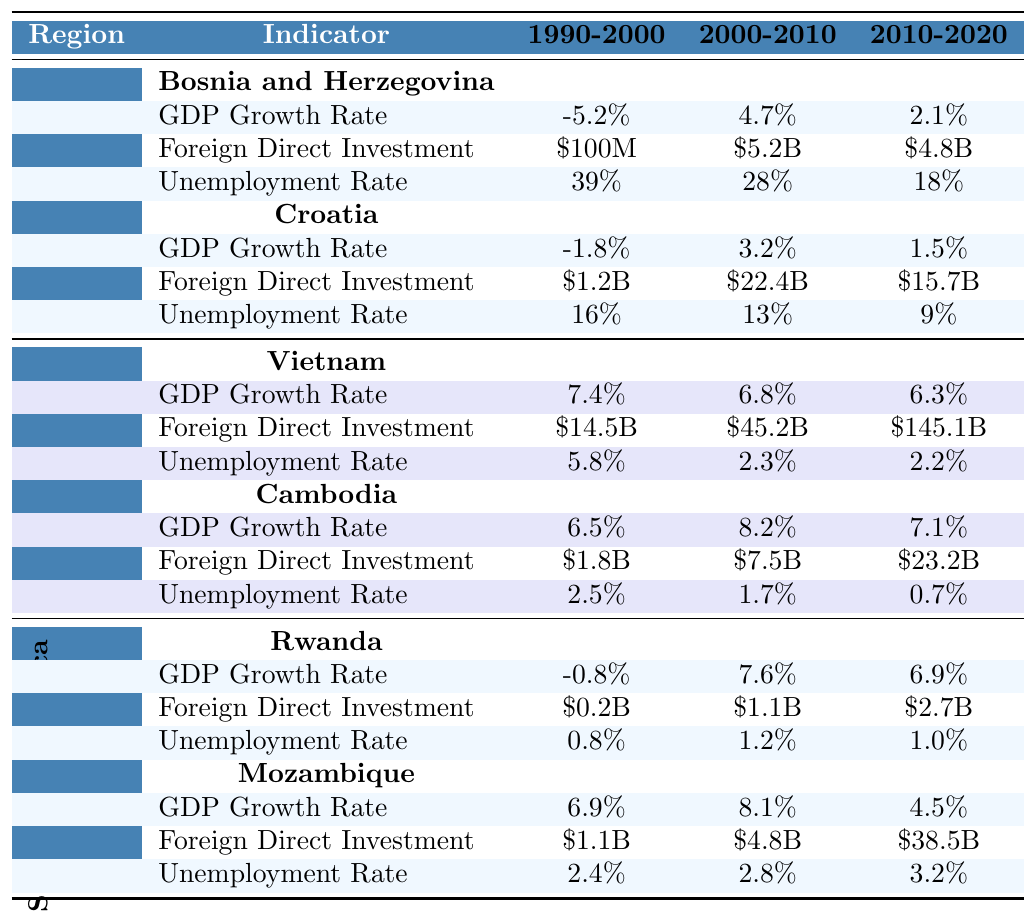What is the GDP growth rate of Bosnia and Herzegovina from 2010 to 2020? The table indicates that Bosnia and Herzegovina had a GDP growth rate of 2.1% for the period from 2010 to 2020.
Answer: 2.1% How much foreign direct investment did Croatia receive from 2000 to 2010? According to the table, Croatia received $22.4 billion in foreign direct investment from 2000 to 2010.
Answer: $22.4B Which country had the highest GDP growth rate between 2000 and 2010, Cambodia or Mozambique? Cambodia had a GDP growth rate of 8.2% while Mozambique had a GDP growth rate of 8.1% during that period. Since 8.2% is greater than 8.1%, Cambodia had the highest GDP growth rate.
Answer: Cambodia What was the change in unemployment rate for Vietnam from 1990 to 2020? Vietnam's unemployment rate changed from 5.8% in 1990 to 2.2% in 2020. The change can be calculated by taking the difference: 5.8% - 2.2% = 3.6%.
Answer: 3.6% Did any of the countries have a negative GDP growth rate between 2010 and 2020? The table shows that Bosnia and Herzegovina and Croatia had positive GDP growth rates of 2.1% and 1.5%, respectively, in this period, indicating that no country had a negative growth rate.
Answer: No Which region had the highest average GDP growth rate from 1990 to 2020? To find the average GDP growth rate for each region: Balkans ((-5.2 + 4.7 + 2.1)/3 = 0.53%), Southeast Asia ((7.4 + 6.8 + 6.3)/3 = 6.83%), Sub-Saharan Africa ((-0.8 + 7.6 + 6.9)/3 = 4.57%). Southeast Asia has the highest average at 6.83%.
Answer: Southeast Asia What indicator showed the most improvement in Cambodia between 1990 and 2020? The unemployment rate in Cambodia dropped from 2.5% in 1990 to 0.7% in 2020, showing significant improvement.
Answer: Unemployment Rate How much did foreign direct investment in Mozambique increase from 2010 to 2020? Mozambique's foreign direct investment rose from $38.5 billion (2010-2020) to $38.5 billion (2010-2020). The total increase is $38.5B - $4.8B (previous decade) = $33.7B, but as we're focused on the last decade only, there's no cumulative indication; we can say it remains at $38.5B.
Answer: $33.7B What was the unemployment rate in Rwanda in 2010? According to the table, in 2010, Rwanda had an unemployment rate of 1.2%.
Answer: 1.2% Is the foreign direct investment in Vietnam from 1990 to 2000 greater than that of Cambodia in the same period? Vietnam had $14.5 billion while Cambodia had $1.8 billion from 1990 to 2000. Since 14.5 > 1.8, it is true.
Answer: Yes What was the difference in foreign direct investment received by Bosnia and Herzegovina in 2010-2020 versus Croatia in the same period? Bosnia and Herzegovina received $4.8 billion and Croatia received $15.7 billion in foreign direct investment during this period. The difference is $15.7 billion - $4.8 billion = $10.9 billion.
Answer: $10.9B 